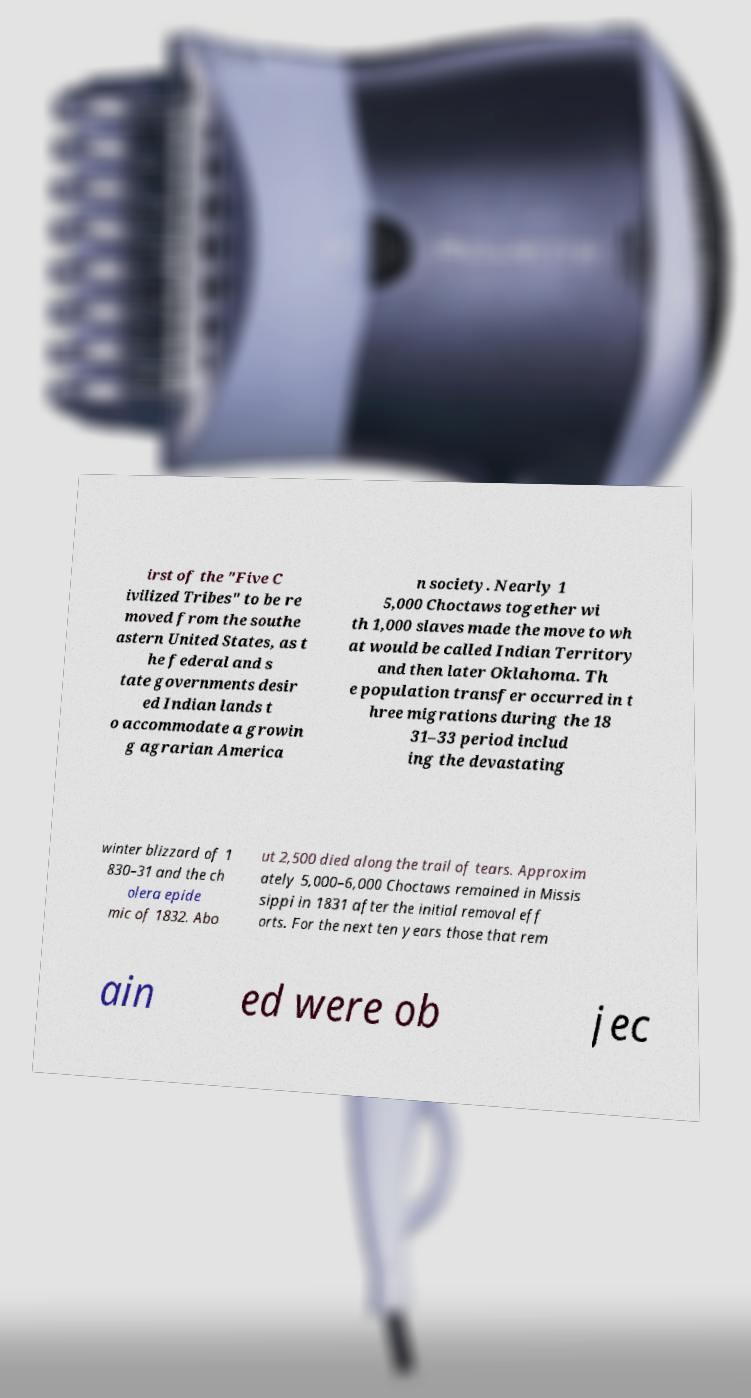Please read and relay the text visible in this image. What does it say? irst of the "Five C ivilized Tribes" to be re moved from the southe astern United States, as t he federal and s tate governments desir ed Indian lands t o accommodate a growin g agrarian America n society. Nearly 1 5,000 Choctaws together wi th 1,000 slaves made the move to wh at would be called Indian Territory and then later Oklahoma. Th e population transfer occurred in t hree migrations during the 18 31–33 period includ ing the devastating winter blizzard of 1 830–31 and the ch olera epide mic of 1832. Abo ut 2,500 died along the trail of tears. Approxim ately 5,000–6,000 Choctaws remained in Missis sippi in 1831 after the initial removal eff orts. For the next ten years those that rem ain ed were ob jec 